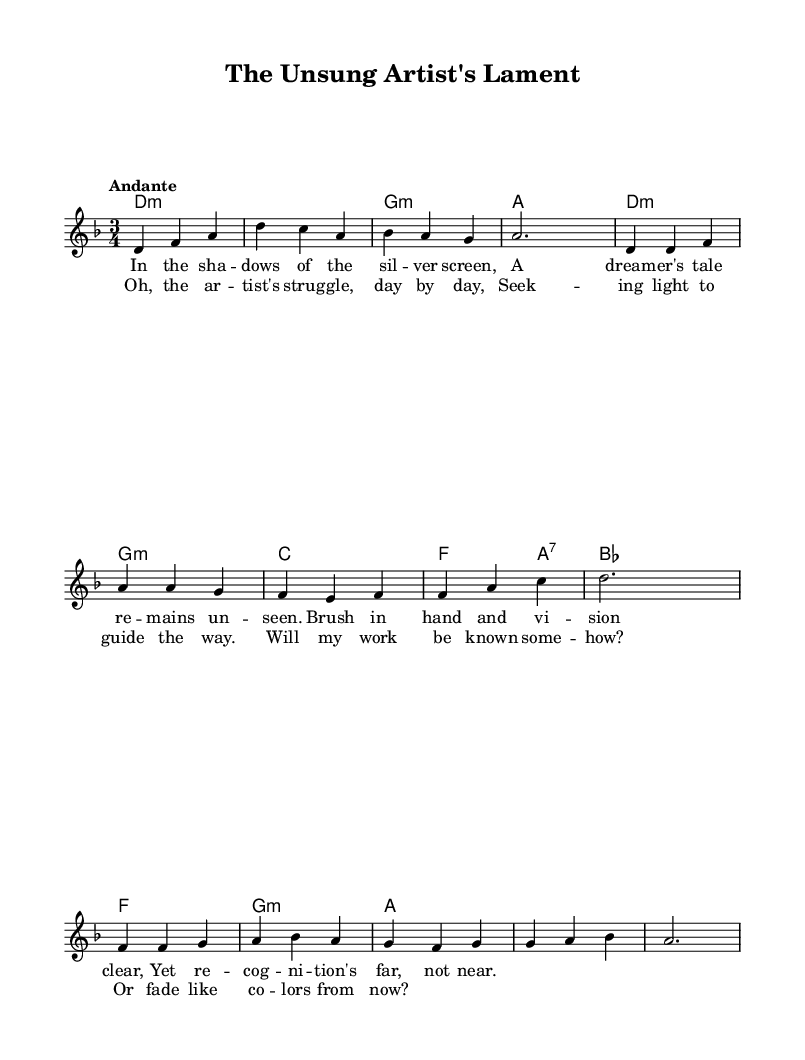What is the key signature of this music? The key signature is indicated by the presence of one flat (B flat), which means it is D minor.
Answer: D minor What is the time signature? The time signature is 3/4, which is shown at the beginning of the score.
Answer: 3/4 What is the tempo marking? The tempo marking at the beginning specifies "Andante," which indicates a fairly moderate pace.
Answer: Andante What is the primary theme of the lyrics? The lyrics focus on the struggles of an artist seeking recognition for their work, as expressed in the phrases about dreams and the search for light.
Answer: Artist's struggle How many measures are in the chorus section? By counting the measures in the chorus, we see that there are four measures, as defined in the musical score.
Answer: Four What type of chords are predominantly used in the verse? The chords primarily used in the verse are minor chords (D minor and G minor).
Answer: Minor chords How do the lyrics reflect the feelings of the artist? The lyrics express feelings of despair and hope, highlighting the contrast between the artist's vision and the lack of recognition.
Answer: Despair and hope 